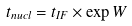<formula> <loc_0><loc_0><loc_500><loc_500>t _ { n u c l } = t _ { I F } \times \exp W</formula> 